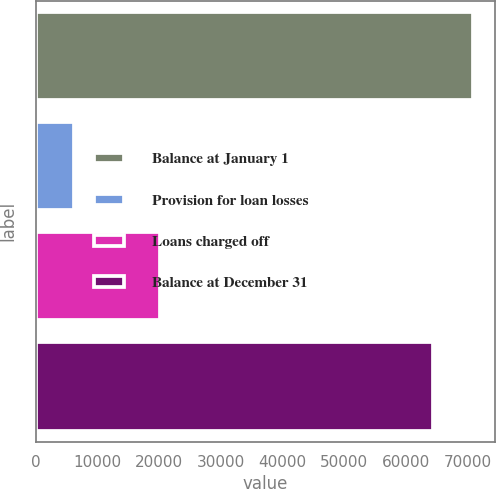Convert chart to OTSL. <chart><loc_0><loc_0><loc_500><loc_500><bar_chart><fcel>Balance at January 1<fcel>Provision for loan losses<fcel>Loans charged off<fcel>Balance at December 31<nl><fcel>70927.7<fcel>6223<fcel>20140<fcel>64500<nl></chart> 